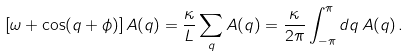Convert formula to latex. <formula><loc_0><loc_0><loc_500><loc_500>\left [ \omega + \cos ( q + \phi ) \right ] A ( q ) = \frac { \kappa } { L } \sum _ { q } A ( q ) = \frac { \kappa } { 2 \pi } \int _ { - \pi } ^ { \pi } d q \, A ( q ) \, .</formula> 